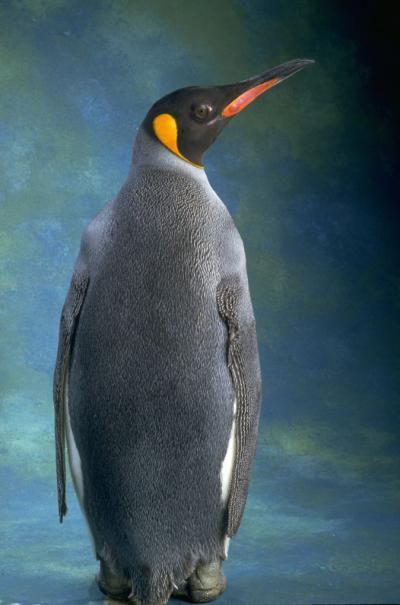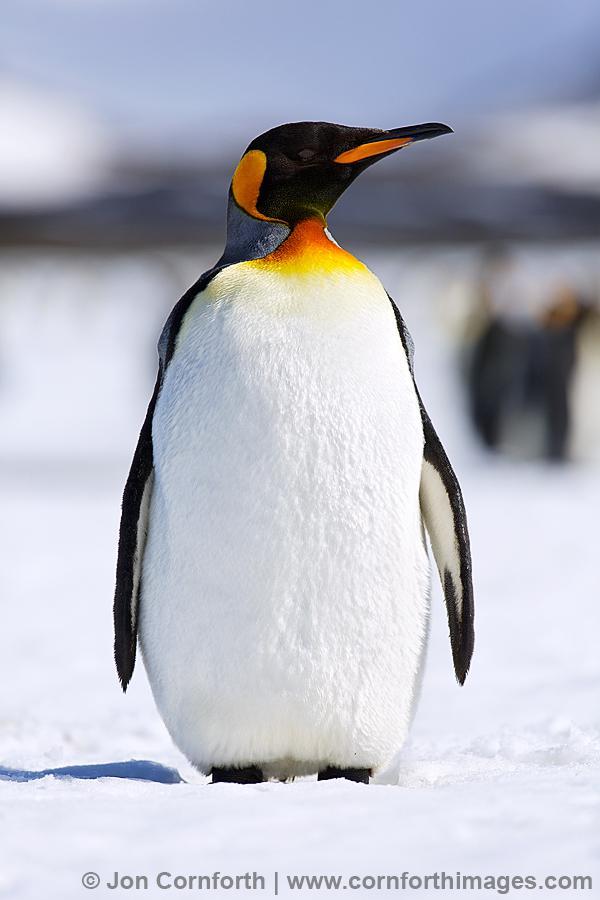The first image is the image on the left, the second image is the image on the right. Evaluate the accuracy of this statement regarding the images: "Each image contains one standing penguin, and all penguins have heads turned rightward.". Is it true? Answer yes or no. Yes. The first image is the image on the left, the second image is the image on the right. Considering the images on both sides, is "There is only one penguin in each image and every penguin looks towards the right." valid? Answer yes or no. Yes. 